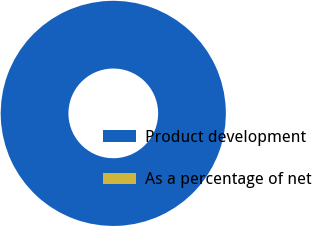Convert chart to OTSL. <chart><loc_0><loc_0><loc_500><loc_500><pie_chart><fcel>Product development<fcel>As a percentage of net<nl><fcel>100.0%<fcel>0.0%<nl></chart> 